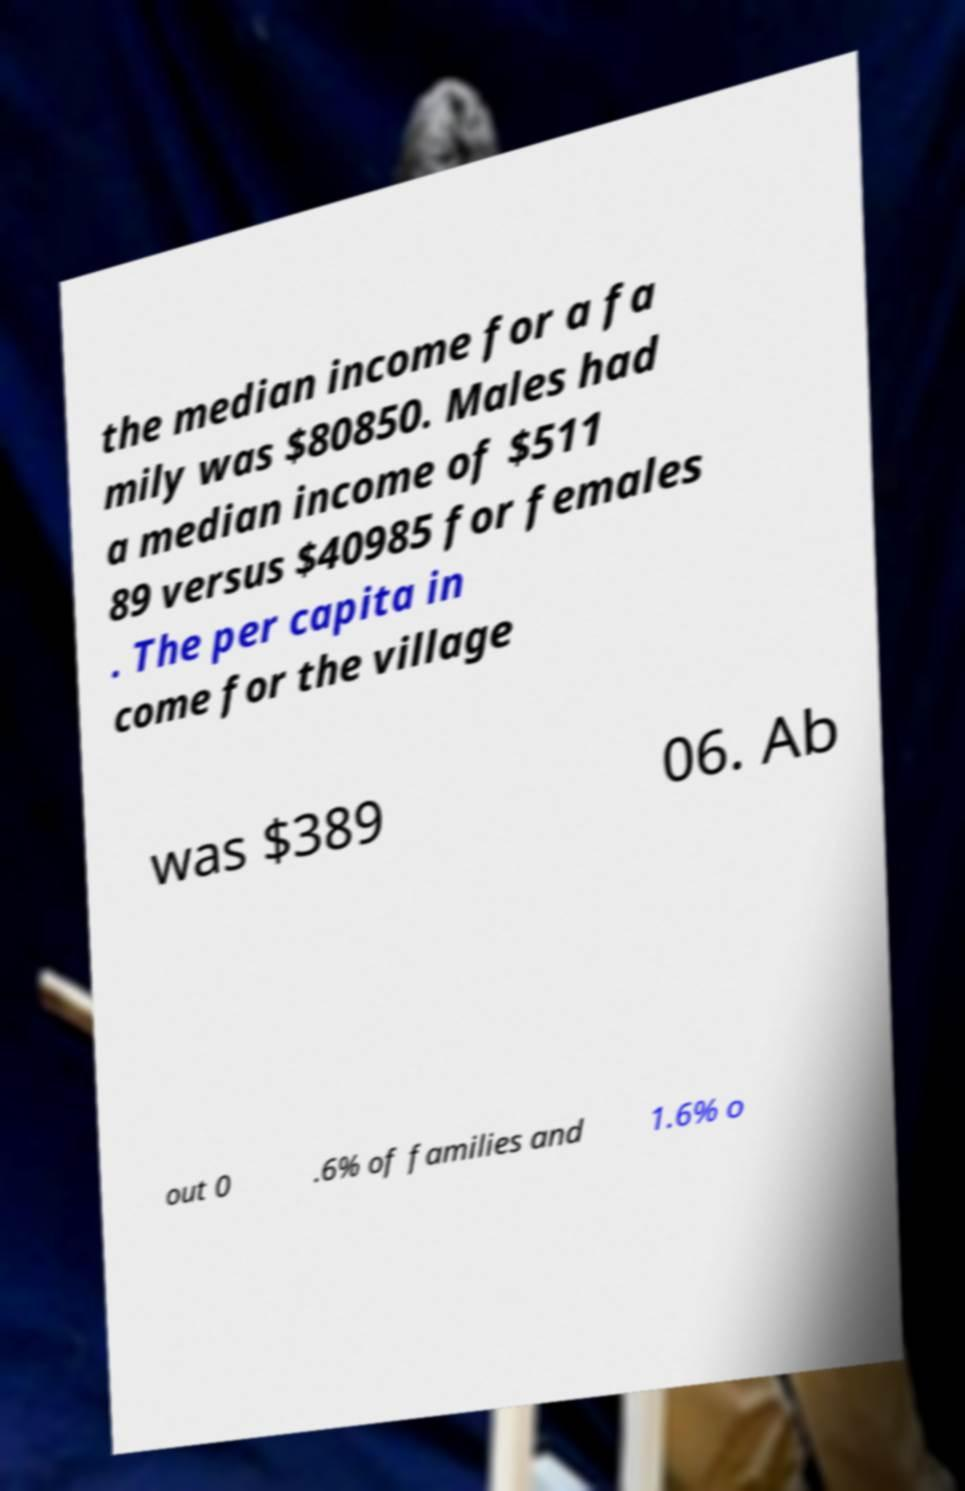Can you read and provide the text displayed in the image?This photo seems to have some interesting text. Can you extract and type it out for me? the median income for a fa mily was $80850. Males had a median income of $511 89 versus $40985 for females . The per capita in come for the village was $389 06. Ab out 0 .6% of families and 1.6% o 